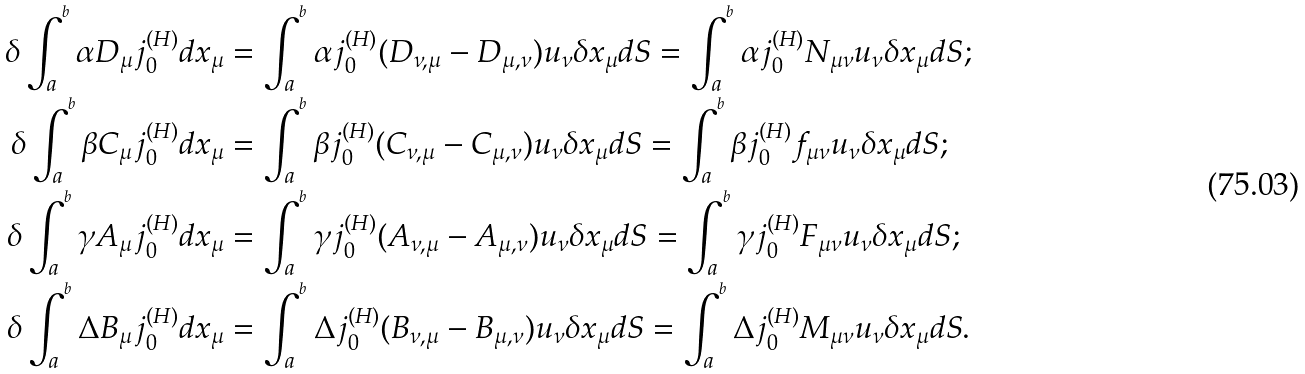Convert formula to latex. <formula><loc_0><loc_0><loc_500><loc_500>\delta \int _ { a } ^ { ^ { b } } \alpha D _ { \mu } j _ { 0 } ^ { ( H ) } d x _ { \mu } & = \int _ { a } ^ { ^ { b } } \alpha j _ { 0 } ^ { ( H ) } ( D _ { \nu , \mu } - D _ { \mu , \nu } ) u _ { \nu } \delta x _ { \mu } d S = \int _ { a } ^ { ^ { b } } \alpha j _ { 0 } ^ { ( H ) } N _ { \mu \nu } u _ { \nu } \delta x _ { \mu } d S ; \\ \delta \int _ { a } ^ { ^ { b } } \beta C _ { \mu } j _ { 0 } ^ { ( H ) } d x _ { \mu } & = \int _ { a } ^ { ^ { b } } \beta j _ { 0 } ^ { ( H ) } ( C _ { \nu , \mu } - C _ { \mu , \nu } ) u _ { \nu } \delta x _ { \mu } d S = \int _ { a } ^ { ^ { b } } \beta j _ { 0 } ^ { ( H ) } f _ { \mu \nu } u _ { \nu } \delta x _ { \mu } d S ; \\ \delta \int _ { a } ^ { ^ { b } } \gamma A _ { \mu } j _ { 0 } ^ { ( H ) } d x _ { \mu } & = \int _ { a } ^ { ^ { b } } \gamma j _ { 0 } ^ { ( H ) } ( A _ { \nu , \mu } - A _ { \mu , \nu } ) u _ { \nu } \delta x _ { \mu } d S = \int _ { a } ^ { ^ { b } } \gamma j _ { 0 } ^ { ( H ) } F _ { \mu \nu } u _ { \nu } \delta x _ { \mu } d S ; \\ \delta \int _ { a } ^ { ^ { b } } \Delta B _ { \mu } j _ { 0 } ^ { ( H ) } d x _ { \mu } & = \int _ { a } ^ { ^ { b } } \Delta j _ { 0 } ^ { ( H ) } ( B _ { \nu , \mu } - B _ { \mu , \nu } ) u _ { \nu } \delta x _ { \mu } d S = \int _ { a } ^ { ^ { b } } \Delta j _ { 0 } ^ { ( H ) } M _ { \mu \nu } u _ { \nu } \delta x _ { \mu } d S .</formula> 